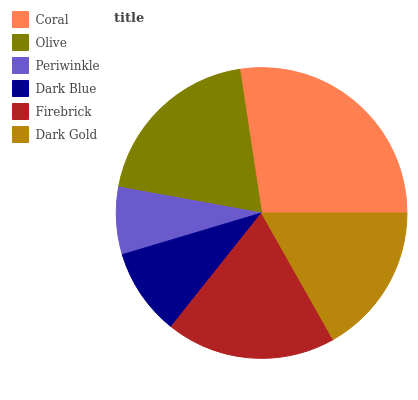Is Periwinkle the minimum?
Answer yes or no. Yes. Is Coral the maximum?
Answer yes or no. Yes. Is Olive the minimum?
Answer yes or no. No. Is Olive the maximum?
Answer yes or no. No. Is Coral greater than Olive?
Answer yes or no. Yes. Is Olive less than Coral?
Answer yes or no. Yes. Is Olive greater than Coral?
Answer yes or no. No. Is Coral less than Olive?
Answer yes or no. No. Is Firebrick the high median?
Answer yes or no. Yes. Is Dark Gold the low median?
Answer yes or no. Yes. Is Dark Gold the high median?
Answer yes or no. No. Is Dark Blue the low median?
Answer yes or no. No. 